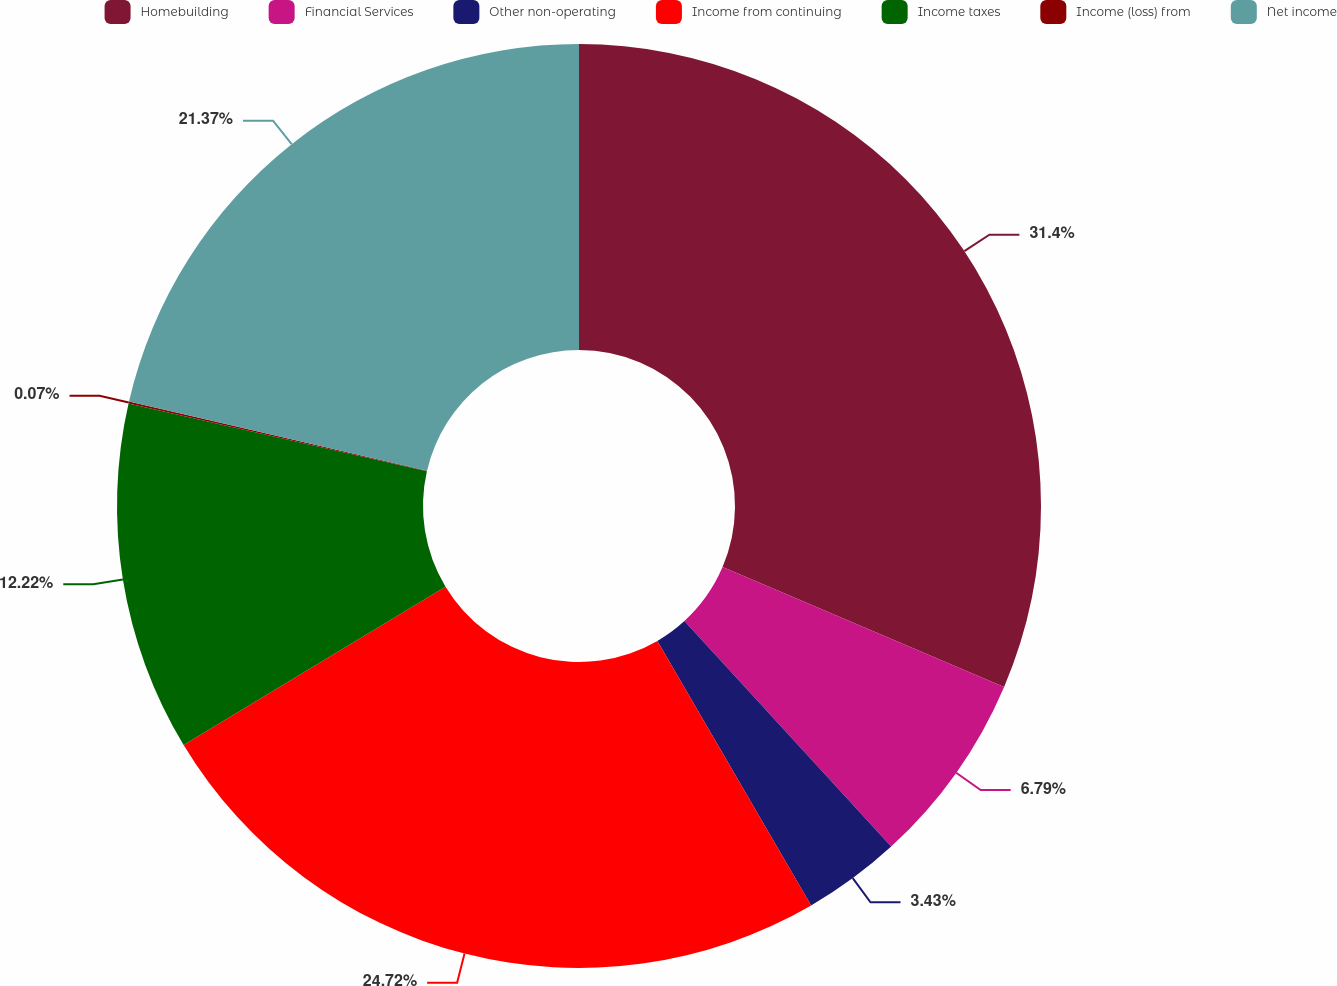Convert chart to OTSL. <chart><loc_0><loc_0><loc_500><loc_500><pie_chart><fcel>Homebuilding<fcel>Financial Services<fcel>Other non-operating<fcel>Income from continuing<fcel>Income taxes<fcel>Income (loss) from<fcel>Net income<nl><fcel>31.41%<fcel>6.79%<fcel>3.43%<fcel>24.73%<fcel>12.22%<fcel>0.07%<fcel>21.37%<nl></chart> 